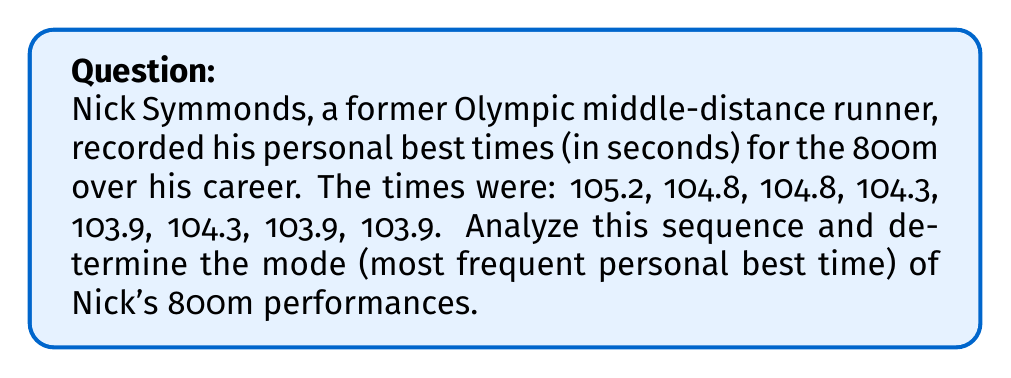Provide a solution to this math problem. To find the mode of Nick Symmonds' personal best times, we need to follow these steps:

1. List all unique times in the sequence:
   $$ 105.2, 104.8, 104.3, 103.9 $$

2. Count the frequency of each time:
   $$ 105.2: 1 \text{ occurrence} $$
   $$ 104.8: 2 \text{ occurrences} $$
   $$ 104.3: 2 \text{ occurrences} $$
   $$ 103.9: 3 \text{ occurrences} $$

3. Identify the time(s) with the highest frequency:
   The time 103.9 seconds appears most frequently, occurring 3 times.

Therefore, the mode of Nick Symmonds' personal best times for the 800m is 103.9 seconds.
Answer: 103.9 seconds 